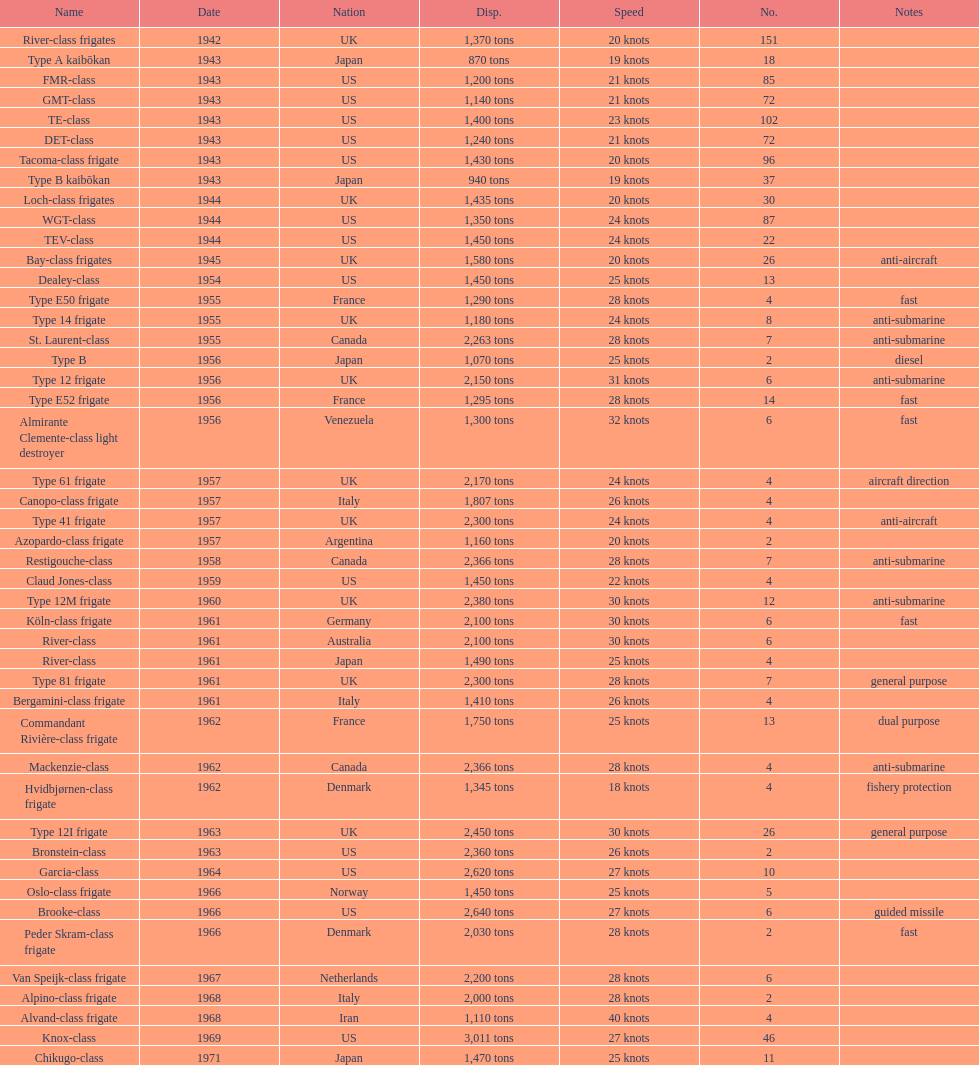Which name has the largest displacement? Knox-class. 